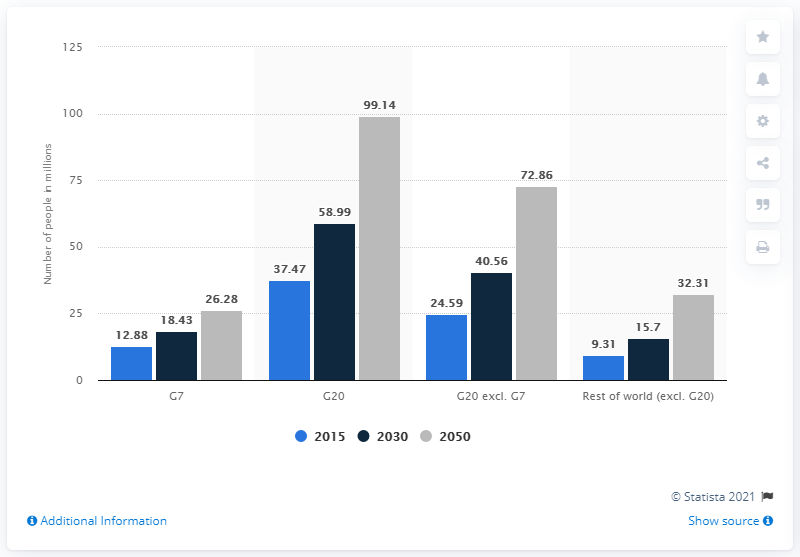Mention a couple of crucial points in this snapshot. According to estimates, the number of people with dementia in G7 countries is projected to reach approximately 18.43 million in 2030. 